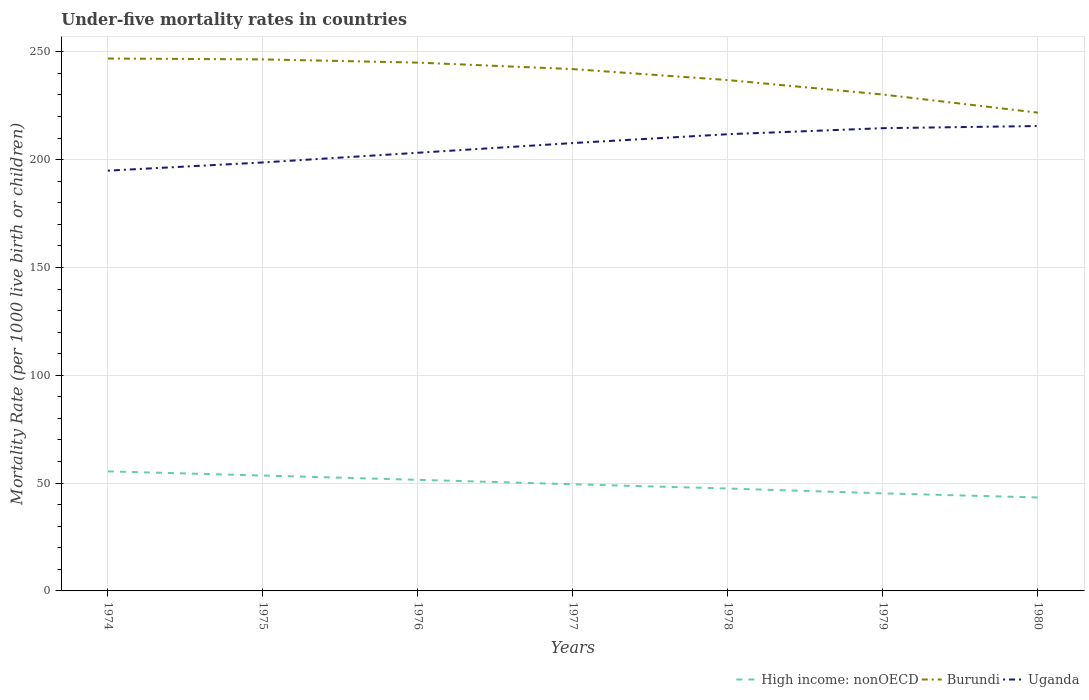Does the line corresponding to Burundi intersect with the line corresponding to High income: nonOECD?
Provide a short and direct response. No. Is the number of lines equal to the number of legend labels?
Provide a short and direct response. Yes. Across all years, what is the maximum under-five mortality rate in High income: nonOECD?
Your answer should be very brief. 43.34. What is the total under-five mortality rate in Uganda in the graph?
Your answer should be very brief. -19.7. What is the difference between the highest and the second highest under-five mortality rate in High income: nonOECD?
Give a very brief answer. 12.1. What is the difference between the highest and the lowest under-five mortality rate in Burundi?
Make the answer very short. 4. Is the under-five mortality rate in Burundi strictly greater than the under-five mortality rate in Uganda over the years?
Provide a succinct answer. No. How many years are there in the graph?
Provide a succinct answer. 7. What is the difference between two consecutive major ticks on the Y-axis?
Give a very brief answer. 50. Are the values on the major ticks of Y-axis written in scientific E-notation?
Your answer should be compact. No. Does the graph contain grids?
Your answer should be compact. Yes. How many legend labels are there?
Your answer should be very brief. 3. What is the title of the graph?
Your answer should be compact. Under-five mortality rates in countries. Does "Middle income" appear as one of the legend labels in the graph?
Offer a terse response. No. What is the label or title of the Y-axis?
Provide a succinct answer. Mortality Rate (per 1000 live birth or children). What is the Mortality Rate (per 1000 live birth or children) of High income: nonOECD in 1974?
Make the answer very short. 55.45. What is the Mortality Rate (per 1000 live birth or children) in Burundi in 1974?
Your answer should be very brief. 246.9. What is the Mortality Rate (per 1000 live birth or children) in Uganda in 1974?
Give a very brief answer. 194.9. What is the Mortality Rate (per 1000 live birth or children) of High income: nonOECD in 1975?
Make the answer very short. 53.51. What is the Mortality Rate (per 1000 live birth or children) in Burundi in 1975?
Provide a succinct answer. 246.5. What is the Mortality Rate (per 1000 live birth or children) in Uganda in 1975?
Offer a very short reply. 198.7. What is the Mortality Rate (per 1000 live birth or children) of High income: nonOECD in 1976?
Keep it short and to the point. 51.52. What is the Mortality Rate (per 1000 live birth or children) in Burundi in 1976?
Your response must be concise. 245. What is the Mortality Rate (per 1000 live birth or children) in Uganda in 1976?
Make the answer very short. 203.2. What is the Mortality Rate (per 1000 live birth or children) in High income: nonOECD in 1977?
Offer a very short reply. 49.47. What is the Mortality Rate (per 1000 live birth or children) in Burundi in 1977?
Your answer should be very brief. 242. What is the Mortality Rate (per 1000 live birth or children) in Uganda in 1977?
Provide a succinct answer. 207.7. What is the Mortality Rate (per 1000 live birth or children) of High income: nonOECD in 1978?
Keep it short and to the point. 47.49. What is the Mortality Rate (per 1000 live birth or children) in Burundi in 1978?
Make the answer very short. 236.9. What is the Mortality Rate (per 1000 live birth or children) of Uganda in 1978?
Provide a succinct answer. 211.8. What is the Mortality Rate (per 1000 live birth or children) of High income: nonOECD in 1979?
Your answer should be compact. 45.25. What is the Mortality Rate (per 1000 live birth or children) of Burundi in 1979?
Offer a very short reply. 230.2. What is the Mortality Rate (per 1000 live birth or children) of Uganda in 1979?
Your response must be concise. 214.6. What is the Mortality Rate (per 1000 live birth or children) in High income: nonOECD in 1980?
Your answer should be compact. 43.34. What is the Mortality Rate (per 1000 live birth or children) in Burundi in 1980?
Give a very brief answer. 221.8. What is the Mortality Rate (per 1000 live birth or children) of Uganda in 1980?
Provide a short and direct response. 215.6. Across all years, what is the maximum Mortality Rate (per 1000 live birth or children) of High income: nonOECD?
Your answer should be compact. 55.45. Across all years, what is the maximum Mortality Rate (per 1000 live birth or children) in Burundi?
Offer a very short reply. 246.9. Across all years, what is the maximum Mortality Rate (per 1000 live birth or children) in Uganda?
Make the answer very short. 215.6. Across all years, what is the minimum Mortality Rate (per 1000 live birth or children) in High income: nonOECD?
Offer a terse response. 43.34. Across all years, what is the minimum Mortality Rate (per 1000 live birth or children) of Burundi?
Give a very brief answer. 221.8. Across all years, what is the minimum Mortality Rate (per 1000 live birth or children) in Uganda?
Provide a short and direct response. 194.9. What is the total Mortality Rate (per 1000 live birth or children) in High income: nonOECD in the graph?
Provide a succinct answer. 346.02. What is the total Mortality Rate (per 1000 live birth or children) in Burundi in the graph?
Keep it short and to the point. 1669.3. What is the total Mortality Rate (per 1000 live birth or children) of Uganda in the graph?
Your response must be concise. 1446.5. What is the difference between the Mortality Rate (per 1000 live birth or children) of High income: nonOECD in 1974 and that in 1975?
Your answer should be compact. 1.94. What is the difference between the Mortality Rate (per 1000 live birth or children) of Burundi in 1974 and that in 1975?
Your response must be concise. 0.4. What is the difference between the Mortality Rate (per 1000 live birth or children) of Uganda in 1974 and that in 1975?
Provide a short and direct response. -3.8. What is the difference between the Mortality Rate (per 1000 live birth or children) in High income: nonOECD in 1974 and that in 1976?
Offer a very short reply. 3.93. What is the difference between the Mortality Rate (per 1000 live birth or children) in High income: nonOECD in 1974 and that in 1977?
Make the answer very short. 5.98. What is the difference between the Mortality Rate (per 1000 live birth or children) of Uganda in 1974 and that in 1977?
Provide a succinct answer. -12.8. What is the difference between the Mortality Rate (per 1000 live birth or children) in High income: nonOECD in 1974 and that in 1978?
Offer a terse response. 7.96. What is the difference between the Mortality Rate (per 1000 live birth or children) of Burundi in 1974 and that in 1978?
Offer a terse response. 10. What is the difference between the Mortality Rate (per 1000 live birth or children) in Uganda in 1974 and that in 1978?
Give a very brief answer. -16.9. What is the difference between the Mortality Rate (per 1000 live birth or children) in High income: nonOECD in 1974 and that in 1979?
Ensure brevity in your answer.  10.2. What is the difference between the Mortality Rate (per 1000 live birth or children) of Uganda in 1974 and that in 1979?
Make the answer very short. -19.7. What is the difference between the Mortality Rate (per 1000 live birth or children) of High income: nonOECD in 1974 and that in 1980?
Your answer should be very brief. 12.1. What is the difference between the Mortality Rate (per 1000 live birth or children) of Burundi in 1974 and that in 1980?
Provide a short and direct response. 25.1. What is the difference between the Mortality Rate (per 1000 live birth or children) in Uganda in 1974 and that in 1980?
Offer a terse response. -20.7. What is the difference between the Mortality Rate (per 1000 live birth or children) in High income: nonOECD in 1975 and that in 1976?
Offer a very short reply. 1.99. What is the difference between the Mortality Rate (per 1000 live birth or children) of Burundi in 1975 and that in 1976?
Provide a short and direct response. 1.5. What is the difference between the Mortality Rate (per 1000 live birth or children) in Uganda in 1975 and that in 1976?
Ensure brevity in your answer.  -4.5. What is the difference between the Mortality Rate (per 1000 live birth or children) of High income: nonOECD in 1975 and that in 1977?
Offer a terse response. 4.04. What is the difference between the Mortality Rate (per 1000 live birth or children) in High income: nonOECD in 1975 and that in 1978?
Ensure brevity in your answer.  6.02. What is the difference between the Mortality Rate (per 1000 live birth or children) of High income: nonOECD in 1975 and that in 1979?
Ensure brevity in your answer.  8.26. What is the difference between the Mortality Rate (per 1000 live birth or children) of Burundi in 1975 and that in 1979?
Offer a very short reply. 16.3. What is the difference between the Mortality Rate (per 1000 live birth or children) of Uganda in 1975 and that in 1979?
Ensure brevity in your answer.  -15.9. What is the difference between the Mortality Rate (per 1000 live birth or children) of High income: nonOECD in 1975 and that in 1980?
Your response must be concise. 10.17. What is the difference between the Mortality Rate (per 1000 live birth or children) of Burundi in 1975 and that in 1980?
Keep it short and to the point. 24.7. What is the difference between the Mortality Rate (per 1000 live birth or children) of Uganda in 1975 and that in 1980?
Ensure brevity in your answer.  -16.9. What is the difference between the Mortality Rate (per 1000 live birth or children) in High income: nonOECD in 1976 and that in 1977?
Offer a very short reply. 2.05. What is the difference between the Mortality Rate (per 1000 live birth or children) in High income: nonOECD in 1976 and that in 1978?
Offer a very short reply. 4.03. What is the difference between the Mortality Rate (per 1000 live birth or children) of Uganda in 1976 and that in 1978?
Provide a short and direct response. -8.6. What is the difference between the Mortality Rate (per 1000 live birth or children) in High income: nonOECD in 1976 and that in 1979?
Ensure brevity in your answer.  6.27. What is the difference between the Mortality Rate (per 1000 live birth or children) of Burundi in 1976 and that in 1979?
Your response must be concise. 14.8. What is the difference between the Mortality Rate (per 1000 live birth or children) in High income: nonOECD in 1976 and that in 1980?
Your answer should be compact. 8.17. What is the difference between the Mortality Rate (per 1000 live birth or children) in Burundi in 1976 and that in 1980?
Offer a terse response. 23.2. What is the difference between the Mortality Rate (per 1000 live birth or children) of High income: nonOECD in 1977 and that in 1978?
Offer a terse response. 1.99. What is the difference between the Mortality Rate (per 1000 live birth or children) in Uganda in 1977 and that in 1978?
Provide a succinct answer. -4.1. What is the difference between the Mortality Rate (per 1000 live birth or children) in High income: nonOECD in 1977 and that in 1979?
Make the answer very short. 4.22. What is the difference between the Mortality Rate (per 1000 live birth or children) in Uganda in 1977 and that in 1979?
Your answer should be very brief. -6.9. What is the difference between the Mortality Rate (per 1000 live birth or children) in High income: nonOECD in 1977 and that in 1980?
Give a very brief answer. 6.13. What is the difference between the Mortality Rate (per 1000 live birth or children) of Burundi in 1977 and that in 1980?
Keep it short and to the point. 20.2. What is the difference between the Mortality Rate (per 1000 live birth or children) of High income: nonOECD in 1978 and that in 1979?
Offer a very short reply. 2.24. What is the difference between the Mortality Rate (per 1000 live birth or children) of High income: nonOECD in 1978 and that in 1980?
Offer a very short reply. 4.14. What is the difference between the Mortality Rate (per 1000 live birth or children) in High income: nonOECD in 1979 and that in 1980?
Your response must be concise. 1.9. What is the difference between the Mortality Rate (per 1000 live birth or children) in Burundi in 1979 and that in 1980?
Your answer should be very brief. 8.4. What is the difference between the Mortality Rate (per 1000 live birth or children) of High income: nonOECD in 1974 and the Mortality Rate (per 1000 live birth or children) of Burundi in 1975?
Provide a short and direct response. -191.05. What is the difference between the Mortality Rate (per 1000 live birth or children) of High income: nonOECD in 1974 and the Mortality Rate (per 1000 live birth or children) of Uganda in 1975?
Give a very brief answer. -143.25. What is the difference between the Mortality Rate (per 1000 live birth or children) in Burundi in 1974 and the Mortality Rate (per 1000 live birth or children) in Uganda in 1975?
Your answer should be compact. 48.2. What is the difference between the Mortality Rate (per 1000 live birth or children) in High income: nonOECD in 1974 and the Mortality Rate (per 1000 live birth or children) in Burundi in 1976?
Provide a short and direct response. -189.55. What is the difference between the Mortality Rate (per 1000 live birth or children) of High income: nonOECD in 1974 and the Mortality Rate (per 1000 live birth or children) of Uganda in 1976?
Make the answer very short. -147.75. What is the difference between the Mortality Rate (per 1000 live birth or children) in Burundi in 1974 and the Mortality Rate (per 1000 live birth or children) in Uganda in 1976?
Your answer should be very brief. 43.7. What is the difference between the Mortality Rate (per 1000 live birth or children) of High income: nonOECD in 1974 and the Mortality Rate (per 1000 live birth or children) of Burundi in 1977?
Provide a succinct answer. -186.55. What is the difference between the Mortality Rate (per 1000 live birth or children) in High income: nonOECD in 1974 and the Mortality Rate (per 1000 live birth or children) in Uganda in 1977?
Provide a short and direct response. -152.25. What is the difference between the Mortality Rate (per 1000 live birth or children) in Burundi in 1974 and the Mortality Rate (per 1000 live birth or children) in Uganda in 1977?
Offer a very short reply. 39.2. What is the difference between the Mortality Rate (per 1000 live birth or children) in High income: nonOECD in 1974 and the Mortality Rate (per 1000 live birth or children) in Burundi in 1978?
Ensure brevity in your answer.  -181.45. What is the difference between the Mortality Rate (per 1000 live birth or children) in High income: nonOECD in 1974 and the Mortality Rate (per 1000 live birth or children) in Uganda in 1978?
Provide a succinct answer. -156.35. What is the difference between the Mortality Rate (per 1000 live birth or children) in Burundi in 1974 and the Mortality Rate (per 1000 live birth or children) in Uganda in 1978?
Give a very brief answer. 35.1. What is the difference between the Mortality Rate (per 1000 live birth or children) of High income: nonOECD in 1974 and the Mortality Rate (per 1000 live birth or children) of Burundi in 1979?
Make the answer very short. -174.75. What is the difference between the Mortality Rate (per 1000 live birth or children) of High income: nonOECD in 1974 and the Mortality Rate (per 1000 live birth or children) of Uganda in 1979?
Make the answer very short. -159.15. What is the difference between the Mortality Rate (per 1000 live birth or children) of Burundi in 1974 and the Mortality Rate (per 1000 live birth or children) of Uganda in 1979?
Provide a succinct answer. 32.3. What is the difference between the Mortality Rate (per 1000 live birth or children) of High income: nonOECD in 1974 and the Mortality Rate (per 1000 live birth or children) of Burundi in 1980?
Ensure brevity in your answer.  -166.35. What is the difference between the Mortality Rate (per 1000 live birth or children) in High income: nonOECD in 1974 and the Mortality Rate (per 1000 live birth or children) in Uganda in 1980?
Provide a succinct answer. -160.15. What is the difference between the Mortality Rate (per 1000 live birth or children) of Burundi in 1974 and the Mortality Rate (per 1000 live birth or children) of Uganda in 1980?
Offer a terse response. 31.3. What is the difference between the Mortality Rate (per 1000 live birth or children) of High income: nonOECD in 1975 and the Mortality Rate (per 1000 live birth or children) of Burundi in 1976?
Keep it short and to the point. -191.49. What is the difference between the Mortality Rate (per 1000 live birth or children) in High income: nonOECD in 1975 and the Mortality Rate (per 1000 live birth or children) in Uganda in 1976?
Your answer should be compact. -149.69. What is the difference between the Mortality Rate (per 1000 live birth or children) of Burundi in 1975 and the Mortality Rate (per 1000 live birth or children) of Uganda in 1976?
Ensure brevity in your answer.  43.3. What is the difference between the Mortality Rate (per 1000 live birth or children) of High income: nonOECD in 1975 and the Mortality Rate (per 1000 live birth or children) of Burundi in 1977?
Provide a short and direct response. -188.49. What is the difference between the Mortality Rate (per 1000 live birth or children) in High income: nonOECD in 1975 and the Mortality Rate (per 1000 live birth or children) in Uganda in 1977?
Your response must be concise. -154.19. What is the difference between the Mortality Rate (per 1000 live birth or children) of Burundi in 1975 and the Mortality Rate (per 1000 live birth or children) of Uganda in 1977?
Your answer should be compact. 38.8. What is the difference between the Mortality Rate (per 1000 live birth or children) of High income: nonOECD in 1975 and the Mortality Rate (per 1000 live birth or children) of Burundi in 1978?
Provide a succinct answer. -183.39. What is the difference between the Mortality Rate (per 1000 live birth or children) of High income: nonOECD in 1975 and the Mortality Rate (per 1000 live birth or children) of Uganda in 1978?
Offer a very short reply. -158.29. What is the difference between the Mortality Rate (per 1000 live birth or children) of Burundi in 1975 and the Mortality Rate (per 1000 live birth or children) of Uganda in 1978?
Make the answer very short. 34.7. What is the difference between the Mortality Rate (per 1000 live birth or children) in High income: nonOECD in 1975 and the Mortality Rate (per 1000 live birth or children) in Burundi in 1979?
Your answer should be compact. -176.69. What is the difference between the Mortality Rate (per 1000 live birth or children) in High income: nonOECD in 1975 and the Mortality Rate (per 1000 live birth or children) in Uganda in 1979?
Your answer should be very brief. -161.09. What is the difference between the Mortality Rate (per 1000 live birth or children) of Burundi in 1975 and the Mortality Rate (per 1000 live birth or children) of Uganda in 1979?
Provide a short and direct response. 31.9. What is the difference between the Mortality Rate (per 1000 live birth or children) of High income: nonOECD in 1975 and the Mortality Rate (per 1000 live birth or children) of Burundi in 1980?
Keep it short and to the point. -168.29. What is the difference between the Mortality Rate (per 1000 live birth or children) of High income: nonOECD in 1975 and the Mortality Rate (per 1000 live birth or children) of Uganda in 1980?
Your response must be concise. -162.09. What is the difference between the Mortality Rate (per 1000 live birth or children) of Burundi in 1975 and the Mortality Rate (per 1000 live birth or children) of Uganda in 1980?
Provide a succinct answer. 30.9. What is the difference between the Mortality Rate (per 1000 live birth or children) of High income: nonOECD in 1976 and the Mortality Rate (per 1000 live birth or children) of Burundi in 1977?
Offer a terse response. -190.48. What is the difference between the Mortality Rate (per 1000 live birth or children) in High income: nonOECD in 1976 and the Mortality Rate (per 1000 live birth or children) in Uganda in 1977?
Offer a terse response. -156.18. What is the difference between the Mortality Rate (per 1000 live birth or children) in Burundi in 1976 and the Mortality Rate (per 1000 live birth or children) in Uganda in 1977?
Provide a short and direct response. 37.3. What is the difference between the Mortality Rate (per 1000 live birth or children) in High income: nonOECD in 1976 and the Mortality Rate (per 1000 live birth or children) in Burundi in 1978?
Provide a succinct answer. -185.38. What is the difference between the Mortality Rate (per 1000 live birth or children) of High income: nonOECD in 1976 and the Mortality Rate (per 1000 live birth or children) of Uganda in 1978?
Give a very brief answer. -160.28. What is the difference between the Mortality Rate (per 1000 live birth or children) in Burundi in 1976 and the Mortality Rate (per 1000 live birth or children) in Uganda in 1978?
Provide a succinct answer. 33.2. What is the difference between the Mortality Rate (per 1000 live birth or children) in High income: nonOECD in 1976 and the Mortality Rate (per 1000 live birth or children) in Burundi in 1979?
Offer a terse response. -178.68. What is the difference between the Mortality Rate (per 1000 live birth or children) of High income: nonOECD in 1976 and the Mortality Rate (per 1000 live birth or children) of Uganda in 1979?
Ensure brevity in your answer.  -163.08. What is the difference between the Mortality Rate (per 1000 live birth or children) in Burundi in 1976 and the Mortality Rate (per 1000 live birth or children) in Uganda in 1979?
Offer a terse response. 30.4. What is the difference between the Mortality Rate (per 1000 live birth or children) of High income: nonOECD in 1976 and the Mortality Rate (per 1000 live birth or children) of Burundi in 1980?
Keep it short and to the point. -170.28. What is the difference between the Mortality Rate (per 1000 live birth or children) in High income: nonOECD in 1976 and the Mortality Rate (per 1000 live birth or children) in Uganda in 1980?
Your response must be concise. -164.08. What is the difference between the Mortality Rate (per 1000 live birth or children) of Burundi in 1976 and the Mortality Rate (per 1000 live birth or children) of Uganda in 1980?
Make the answer very short. 29.4. What is the difference between the Mortality Rate (per 1000 live birth or children) of High income: nonOECD in 1977 and the Mortality Rate (per 1000 live birth or children) of Burundi in 1978?
Make the answer very short. -187.43. What is the difference between the Mortality Rate (per 1000 live birth or children) in High income: nonOECD in 1977 and the Mortality Rate (per 1000 live birth or children) in Uganda in 1978?
Provide a short and direct response. -162.33. What is the difference between the Mortality Rate (per 1000 live birth or children) in Burundi in 1977 and the Mortality Rate (per 1000 live birth or children) in Uganda in 1978?
Provide a short and direct response. 30.2. What is the difference between the Mortality Rate (per 1000 live birth or children) of High income: nonOECD in 1977 and the Mortality Rate (per 1000 live birth or children) of Burundi in 1979?
Your answer should be compact. -180.73. What is the difference between the Mortality Rate (per 1000 live birth or children) in High income: nonOECD in 1977 and the Mortality Rate (per 1000 live birth or children) in Uganda in 1979?
Keep it short and to the point. -165.13. What is the difference between the Mortality Rate (per 1000 live birth or children) in Burundi in 1977 and the Mortality Rate (per 1000 live birth or children) in Uganda in 1979?
Offer a terse response. 27.4. What is the difference between the Mortality Rate (per 1000 live birth or children) in High income: nonOECD in 1977 and the Mortality Rate (per 1000 live birth or children) in Burundi in 1980?
Your answer should be compact. -172.33. What is the difference between the Mortality Rate (per 1000 live birth or children) of High income: nonOECD in 1977 and the Mortality Rate (per 1000 live birth or children) of Uganda in 1980?
Offer a very short reply. -166.13. What is the difference between the Mortality Rate (per 1000 live birth or children) in Burundi in 1977 and the Mortality Rate (per 1000 live birth or children) in Uganda in 1980?
Make the answer very short. 26.4. What is the difference between the Mortality Rate (per 1000 live birth or children) in High income: nonOECD in 1978 and the Mortality Rate (per 1000 live birth or children) in Burundi in 1979?
Your response must be concise. -182.71. What is the difference between the Mortality Rate (per 1000 live birth or children) of High income: nonOECD in 1978 and the Mortality Rate (per 1000 live birth or children) of Uganda in 1979?
Ensure brevity in your answer.  -167.11. What is the difference between the Mortality Rate (per 1000 live birth or children) in Burundi in 1978 and the Mortality Rate (per 1000 live birth or children) in Uganda in 1979?
Keep it short and to the point. 22.3. What is the difference between the Mortality Rate (per 1000 live birth or children) in High income: nonOECD in 1978 and the Mortality Rate (per 1000 live birth or children) in Burundi in 1980?
Keep it short and to the point. -174.31. What is the difference between the Mortality Rate (per 1000 live birth or children) of High income: nonOECD in 1978 and the Mortality Rate (per 1000 live birth or children) of Uganda in 1980?
Your answer should be very brief. -168.11. What is the difference between the Mortality Rate (per 1000 live birth or children) in Burundi in 1978 and the Mortality Rate (per 1000 live birth or children) in Uganda in 1980?
Your answer should be very brief. 21.3. What is the difference between the Mortality Rate (per 1000 live birth or children) of High income: nonOECD in 1979 and the Mortality Rate (per 1000 live birth or children) of Burundi in 1980?
Provide a succinct answer. -176.55. What is the difference between the Mortality Rate (per 1000 live birth or children) in High income: nonOECD in 1979 and the Mortality Rate (per 1000 live birth or children) in Uganda in 1980?
Provide a short and direct response. -170.35. What is the average Mortality Rate (per 1000 live birth or children) of High income: nonOECD per year?
Offer a very short reply. 49.43. What is the average Mortality Rate (per 1000 live birth or children) of Burundi per year?
Your answer should be compact. 238.47. What is the average Mortality Rate (per 1000 live birth or children) in Uganda per year?
Keep it short and to the point. 206.64. In the year 1974, what is the difference between the Mortality Rate (per 1000 live birth or children) in High income: nonOECD and Mortality Rate (per 1000 live birth or children) in Burundi?
Your answer should be very brief. -191.45. In the year 1974, what is the difference between the Mortality Rate (per 1000 live birth or children) in High income: nonOECD and Mortality Rate (per 1000 live birth or children) in Uganda?
Ensure brevity in your answer.  -139.45. In the year 1974, what is the difference between the Mortality Rate (per 1000 live birth or children) of Burundi and Mortality Rate (per 1000 live birth or children) of Uganda?
Offer a very short reply. 52. In the year 1975, what is the difference between the Mortality Rate (per 1000 live birth or children) of High income: nonOECD and Mortality Rate (per 1000 live birth or children) of Burundi?
Your answer should be compact. -192.99. In the year 1975, what is the difference between the Mortality Rate (per 1000 live birth or children) in High income: nonOECD and Mortality Rate (per 1000 live birth or children) in Uganda?
Offer a very short reply. -145.19. In the year 1975, what is the difference between the Mortality Rate (per 1000 live birth or children) in Burundi and Mortality Rate (per 1000 live birth or children) in Uganda?
Keep it short and to the point. 47.8. In the year 1976, what is the difference between the Mortality Rate (per 1000 live birth or children) of High income: nonOECD and Mortality Rate (per 1000 live birth or children) of Burundi?
Give a very brief answer. -193.48. In the year 1976, what is the difference between the Mortality Rate (per 1000 live birth or children) of High income: nonOECD and Mortality Rate (per 1000 live birth or children) of Uganda?
Your answer should be very brief. -151.68. In the year 1976, what is the difference between the Mortality Rate (per 1000 live birth or children) in Burundi and Mortality Rate (per 1000 live birth or children) in Uganda?
Keep it short and to the point. 41.8. In the year 1977, what is the difference between the Mortality Rate (per 1000 live birth or children) in High income: nonOECD and Mortality Rate (per 1000 live birth or children) in Burundi?
Your answer should be very brief. -192.53. In the year 1977, what is the difference between the Mortality Rate (per 1000 live birth or children) of High income: nonOECD and Mortality Rate (per 1000 live birth or children) of Uganda?
Your answer should be very brief. -158.23. In the year 1977, what is the difference between the Mortality Rate (per 1000 live birth or children) in Burundi and Mortality Rate (per 1000 live birth or children) in Uganda?
Ensure brevity in your answer.  34.3. In the year 1978, what is the difference between the Mortality Rate (per 1000 live birth or children) of High income: nonOECD and Mortality Rate (per 1000 live birth or children) of Burundi?
Your response must be concise. -189.41. In the year 1978, what is the difference between the Mortality Rate (per 1000 live birth or children) in High income: nonOECD and Mortality Rate (per 1000 live birth or children) in Uganda?
Your response must be concise. -164.31. In the year 1978, what is the difference between the Mortality Rate (per 1000 live birth or children) in Burundi and Mortality Rate (per 1000 live birth or children) in Uganda?
Provide a succinct answer. 25.1. In the year 1979, what is the difference between the Mortality Rate (per 1000 live birth or children) in High income: nonOECD and Mortality Rate (per 1000 live birth or children) in Burundi?
Ensure brevity in your answer.  -184.95. In the year 1979, what is the difference between the Mortality Rate (per 1000 live birth or children) in High income: nonOECD and Mortality Rate (per 1000 live birth or children) in Uganda?
Offer a terse response. -169.35. In the year 1979, what is the difference between the Mortality Rate (per 1000 live birth or children) in Burundi and Mortality Rate (per 1000 live birth or children) in Uganda?
Make the answer very short. 15.6. In the year 1980, what is the difference between the Mortality Rate (per 1000 live birth or children) in High income: nonOECD and Mortality Rate (per 1000 live birth or children) in Burundi?
Your answer should be compact. -178.46. In the year 1980, what is the difference between the Mortality Rate (per 1000 live birth or children) of High income: nonOECD and Mortality Rate (per 1000 live birth or children) of Uganda?
Your answer should be compact. -172.26. In the year 1980, what is the difference between the Mortality Rate (per 1000 live birth or children) of Burundi and Mortality Rate (per 1000 live birth or children) of Uganda?
Give a very brief answer. 6.2. What is the ratio of the Mortality Rate (per 1000 live birth or children) in High income: nonOECD in 1974 to that in 1975?
Your answer should be compact. 1.04. What is the ratio of the Mortality Rate (per 1000 live birth or children) in Burundi in 1974 to that in 1975?
Give a very brief answer. 1. What is the ratio of the Mortality Rate (per 1000 live birth or children) in Uganda in 1974 to that in 1975?
Your response must be concise. 0.98. What is the ratio of the Mortality Rate (per 1000 live birth or children) of High income: nonOECD in 1974 to that in 1976?
Provide a short and direct response. 1.08. What is the ratio of the Mortality Rate (per 1000 live birth or children) of Burundi in 1974 to that in 1976?
Offer a terse response. 1.01. What is the ratio of the Mortality Rate (per 1000 live birth or children) in Uganda in 1974 to that in 1976?
Ensure brevity in your answer.  0.96. What is the ratio of the Mortality Rate (per 1000 live birth or children) in High income: nonOECD in 1974 to that in 1977?
Ensure brevity in your answer.  1.12. What is the ratio of the Mortality Rate (per 1000 live birth or children) in Burundi in 1974 to that in 1977?
Ensure brevity in your answer.  1.02. What is the ratio of the Mortality Rate (per 1000 live birth or children) in Uganda in 1974 to that in 1977?
Keep it short and to the point. 0.94. What is the ratio of the Mortality Rate (per 1000 live birth or children) in High income: nonOECD in 1974 to that in 1978?
Provide a short and direct response. 1.17. What is the ratio of the Mortality Rate (per 1000 live birth or children) of Burundi in 1974 to that in 1978?
Provide a succinct answer. 1.04. What is the ratio of the Mortality Rate (per 1000 live birth or children) in Uganda in 1974 to that in 1978?
Your answer should be very brief. 0.92. What is the ratio of the Mortality Rate (per 1000 live birth or children) in High income: nonOECD in 1974 to that in 1979?
Your answer should be very brief. 1.23. What is the ratio of the Mortality Rate (per 1000 live birth or children) in Burundi in 1974 to that in 1979?
Offer a very short reply. 1.07. What is the ratio of the Mortality Rate (per 1000 live birth or children) in Uganda in 1974 to that in 1979?
Your response must be concise. 0.91. What is the ratio of the Mortality Rate (per 1000 live birth or children) in High income: nonOECD in 1974 to that in 1980?
Keep it short and to the point. 1.28. What is the ratio of the Mortality Rate (per 1000 live birth or children) of Burundi in 1974 to that in 1980?
Your answer should be very brief. 1.11. What is the ratio of the Mortality Rate (per 1000 live birth or children) in Uganda in 1974 to that in 1980?
Offer a terse response. 0.9. What is the ratio of the Mortality Rate (per 1000 live birth or children) in High income: nonOECD in 1975 to that in 1976?
Your response must be concise. 1.04. What is the ratio of the Mortality Rate (per 1000 live birth or children) of Uganda in 1975 to that in 1976?
Offer a very short reply. 0.98. What is the ratio of the Mortality Rate (per 1000 live birth or children) of High income: nonOECD in 1975 to that in 1977?
Offer a terse response. 1.08. What is the ratio of the Mortality Rate (per 1000 live birth or children) in Burundi in 1975 to that in 1977?
Provide a succinct answer. 1.02. What is the ratio of the Mortality Rate (per 1000 live birth or children) in Uganda in 1975 to that in 1977?
Give a very brief answer. 0.96. What is the ratio of the Mortality Rate (per 1000 live birth or children) in High income: nonOECD in 1975 to that in 1978?
Ensure brevity in your answer.  1.13. What is the ratio of the Mortality Rate (per 1000 live birth or children) of Burundi in 1975 to that in 1978?
Give a very brief answer. 1.04. What is the ratio of the Mortality Rate (per 1000 live birth or children) of Uganda in 1975 to that in 1978?
Give a very brief answer. 0.94. What is the ratio of the Mortality Rate (per 1000 live birth or children) of High income: nonOECD in 1975 to that in 1979?
Offer a very short reply. 1.18. What is the ratio of the Mortality Rate (per 1000 live birth or children) in Burundi in 1975 to that in 1979?
Ensure brevity in your answer.  1.07. What is the ratio of the Mortality Rate (per 1000 live birth or children) in Uganda in 1975 to that in 1979?
Give a very brief answer. 0.93. What is the ratio of the Mortality Rate (per 1000 live birth or children) in High income: nonOECD in 1975 to that in 1980?
Offer a terse response. 1.23. What is the ratio of the Mortality Rate (per 1000 live birth or children) of Burundi in 1975 to that in 1980?
Offer a very short reply. 1.11. What is the ratio of the Mortality Rate (per 1000 live birth or children) of Uganda in 1975 to that in 1980?
Give a very brief answer. 0.92. What is the ratio of the Mortality Rate (per 1000 live birth or children) of High income: nonOECD in 1976 to that in 1977?
Your answer should be very brief. 1.04. What is the ratio of the Mortality Rate (per 1000 live birth or children) in Burundi in 1976 to that in 1977?
Your answer should be compact. 1.01. What is the ratio of the Mortality Rate (per 1000 live birth or children) of Uganda in 1976 to that in 1977?
Make the answer very short. 0.98. What is the ratio of the Mortality Rate (per 1000 live birth or children) of High income: nonOECD in 1976 to that in 1978?
Offer a very short reply. 1.08. What is the ratio of the Mortality Rate (per 1000 live birth or children) in Burundi in 1976 to that in 1978?
Ensure brevity in your answer.  1.03. What is the ratio of the Mortality Rate (per 1000 live birth or children) of Uganda in 1976 to that in 1978?
Provide a succinct answer. 0.96. What is the ratio of the Mortality Rate (per 1000 live birth or children) of High income: nonOECD in 1976 to that in 1979?
Offer a very short reply. 1.14. What is the ratio of the Mortality Rate (per 1000 live birth or children) of Burundi in 1976 to that in 1979?
Your response must be concise. 1.06. What is the ratio of the Mortality Rate (per 1000 live birth or children) in Uganda in 1976 to that in 1979?
Give a very brief answer. 0.95. What is the ratio of the Mortality Rate (per 1000 live birth or children) in High income: nonOECD in 1976 to that in 1980?
Your answer should be compact. 1.19. What is the ratio of the Mortality Rate (per 1000 live birth or children) in Burundi in 1976 to that in 1980?
Ensure brevity in your answer.  1.1. What is the ratio of the Mortality Rate (per 1000 live birth or children) in Uganda in 1976 to that in 1980?
Your answer should be very brief. 0.94. What is the ratio of the Mortality Rate (per 1000 live birth or children) of High income: nonOECD in 1977 to that in 1978?
Make the answer very short. 1.04. What is the ratio of the Mortality Rate (per 1000 live birth or children) in Burundi in 1977 to that in 1978?
Your response must be concise. 1.02. What is the ratio of the Mortality Rate (per 1000 live birth or children) in Uganda in 1977 to that in 1978?
Provide a succinct answer. 0.98. What is the ratio of the Mortality Rate (per 1000 live birth or children) in High income: nonOECD in 1977 to that in 1979?
Your answer should be very brief. 1.09. What is the ratio of the Mortality Rate (per 1000 live birth or children) in Burundi in 1977 to that in 1979?
Keep it short and to the point. 1.05. What is the ratio of the Mortality Rate (per 1000 live birth or children) of Uganda in 1977 to that in 1979?
Your response must be concise. 0.97. What is the ratio of the Mortality Rate (per 1000 live birth or children) in High income: nonOECD in 1977 to that in 1980?
Provide a succinct answer. 1.14. What is the ratio of the Mortality Rate (per 1000 live birth or children) in Burundi in 1977 to that in 1980?
Your answer should be compact. 1.09. What is the ratio of the Mortality Rate (per 1000 live birth or children) in Uganda in 1977 to that in 1980?
Your answer should be compact. 0.96. What is the ratio of the Mortality Rate (per 1000 live birth or children) in High income: nonOECD in 1978 to that in 1979?
Offer a terse response. 1.05. What is the ratio of the Mortality Rate (per 1000 live birth or children) in Burundi in 1978 to that in 1979?
Your answer should be compact. 1.03. What is the ratio of the Mortality Rate (per 1000 live birth or children) of Uganda in 1978 to that in 1979?
Make the answer very short. 0.99. What is the ratio of the Mortality Rate (per 1000 live birth or children) of High income: nonOECD in 1978 to that in 1980?
Provide a short and direct response. 1.1. What is the ratio of the Mortality Rate (per 1000 live birth or children) of Burundi in 1978 to that in 1980?
Offer a very short reply. 1.07. What is the ratio of the Mortality Rate (per 1000 live birth or children) of Uganda in 1978 to that in 1980?
Your answer should be compact. 0.98. What is the ratio of the Mortality Rate (per 1000 live birth or children) of High income: nonOECD in 1979 to that in 1980?
Provide a succinct answer. 1.04. What is the ratio of the Mortality Rate (per 1000 live birth or children) of Burundi in 1979 to that in 1980?
Provide a short and direct response. 1.04. What is the ratio of the Mortality Rate (per 1000 live birth or children) in Uganda in 1979 to that in 1980?
Ensure brevity in your answer.  1. What is the difference between the highest and the second highest Mortality Rate (per 1000 live birth or children) of High income: nonOECD?
Provide a short and direct response. 1.94. What is the difference between the highest and the second highest Mortality Rate (per 1000 live birth or children) in Burundi?
Provide a succinct answer. 0.4. What is the difference between the highest and the second highest Mortality Rate (per 1000 live birth or children) of Uganda?
Provide a succinct answer. 1. What is the difference between the highest and the lowest Mortality Rate (per 1000 live birth or children) of High income: nonOECD?
Give a very brief answer. 12.1. What is the difference between the highest and the lowest Mortality Rate (per 1000 live birth or children) of Burundi?
Ensure brevity in your answer.  25.1. What is the difference between the highest and the lowest Mortality Rate (per 1000 live birth or children) in Uganda?
Ensure brevity in your answer.  20.7. 